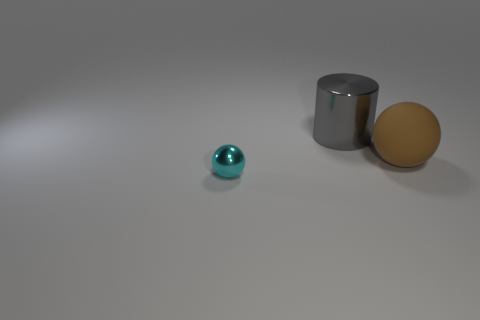Add 1 large rubber spheres. How many objects exist? 4 Subtract all cylinders. How many objects are left? 2 Add 3 large gray rubber spheres. How many large gray rubber spheres exist? 3 Subtract 0 blue balls. How many objects are left? 3 Subtract all big purple rubber objects. Subtract all cyan metal balls. How many objects are left? 2 Add 1 big gray metal objects. How many big gray metal objects are left? 2 